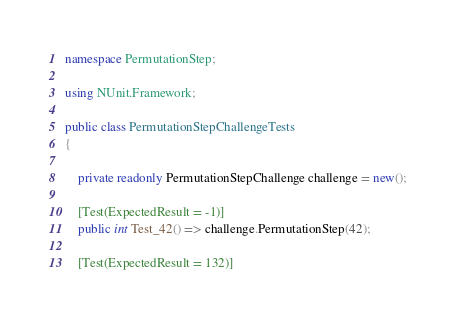Convert code to text. <code><loc_0><loc_0><loc_500><loc_500><_C#_>namespace PermutationStep;

using NUnit.Framework;

public class PermutationStepChallengeTests
{

    private readonly PermutationStepChallenge challenge = new();

    [Test(ExpectedResult = -1)]
    public int Test_42() => challenge.PermutationStep(42);

    [Test(ExpectedResult = 132)]</code> 